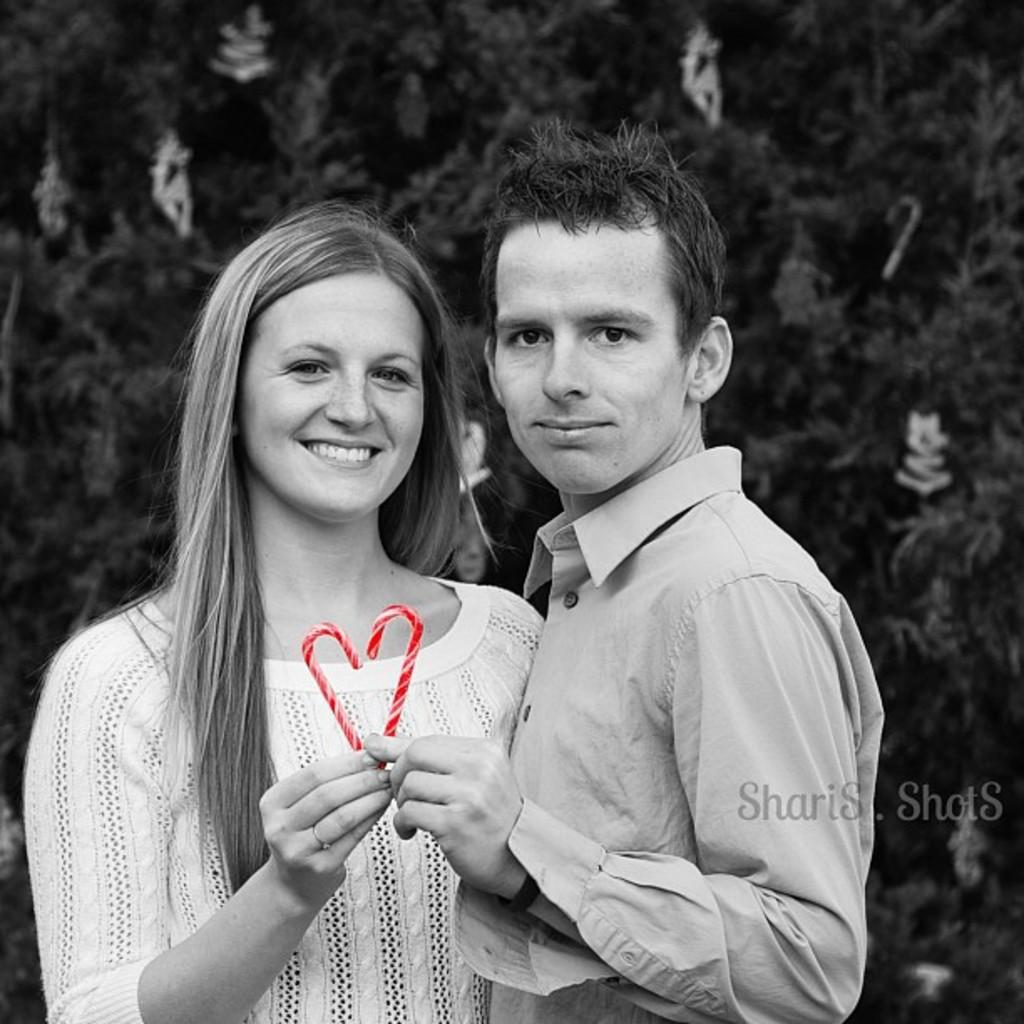Where was the image taken? The image is taken outdoors. What can be seen in the background of the image? There is a Christmas tree in the background. Who are the people in the image? There is a man and a woman in the middle of the image. What are the man and woman holding in their hands? The man and woman are holding two straws in their hands. How many houses are visible in the image? There are no houses visible in the image. What type of carriage is being pulled by the reindeer in the image? There are no reindeer or carriages present in the image. 